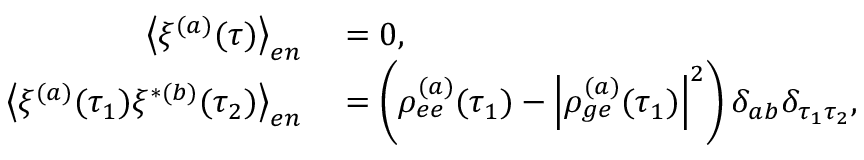Convert formula to latex. <formula><loc_0><loc_0><loc_500><loc_500>\begin{array} { r l } { \left \langle \xi ^ { ( a ) } ( \tau ) \right \rangle _ { e n } } & = 0 , } \\ { \left \langle \xi ^ { ( a ) } ( \tau _ { 1 } ) \xi ^ { * ( b ) } ( \tau _ { 2 } ) \right \rangle _ { e n } } & = \left ( \rho _ { e e } ^ { ( a ) } ( \tau _ { 1 } ) - \left | \rho _ { g e } ^ { ( a ) } ( \tau _ { 1 } ) \right | ^ { 2 } \right ) \delta _ { a b } \delta _ { \tau _ { 1 } \tau _ { 2 } } , } \end{array}</formula> 